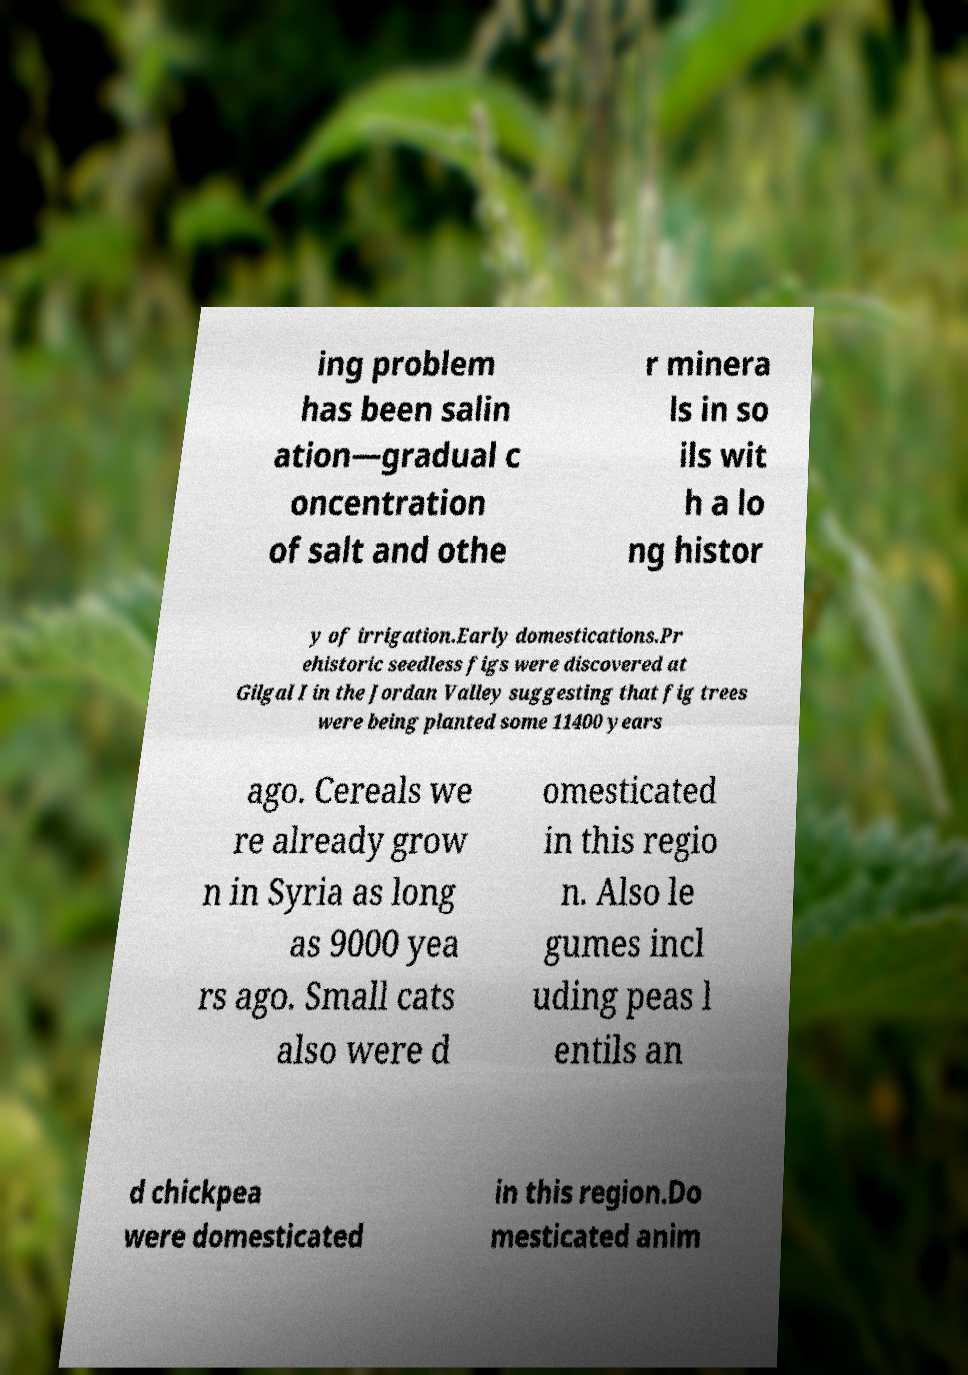For documentation purposes, I need the text within this image transcribed. Could you provide that? ing problem has been salin ation—gradual c oncentration of salt and othe r minera ls in so ils wit h a lo ng histor y of irrigation.Early domestications.Pr ehistoric seedless figs were discovered at Gilgal I in the Jordan Valley suggesting that fig trees were being planted some 11400 years ago. Cereals we re already grow n in Syria as long as 9000 yea rs ago. Small cats also were d omesticated in this regio n. Also le gumes incl uding peas l entils an d chickpea were domesticated in this region.Do mesticated anim 